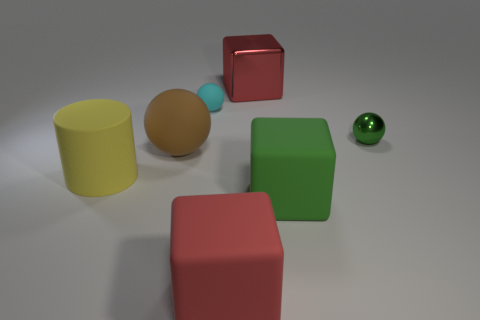Add 3 big brown rubber balls. How many objects exist? 10 Subtract all cylinders. How many objects are left? 6 Subtract all big cylinders. Subtract all tiny cyan cubes. How many objects are left? 6 Add 4 red rubber things. How many red rubber things are left? 5 Add 6 big brown spheres. How many big brown spheres exist? 7 Subtract 0 blue spheres. How many objects are left? 7 